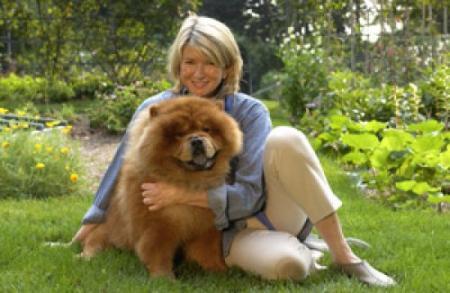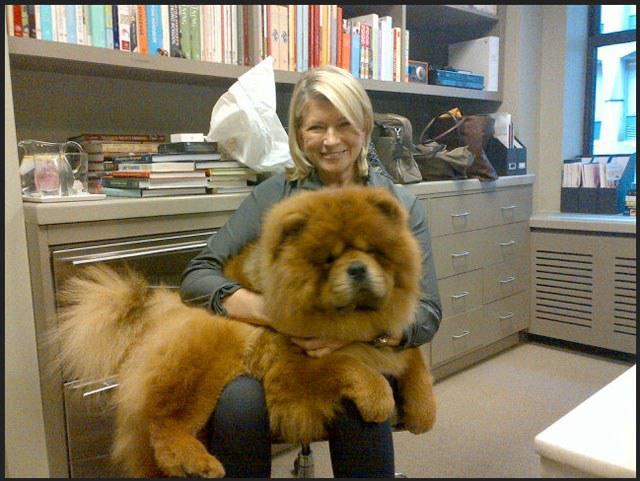The first image is the image on the left, the second image is the image on the right. For the images shown, is this caption "The left image features a person holding at least two chow puppies in front of their chest." true? Answer yes or no. No. The first image is the image on the left, the second image is the image on the right. Analyze the images presented: Is the assertion "A person is holding at least two fluffy Chow Chow puppies in the image on the left." valid? Answer yes or no. No. 